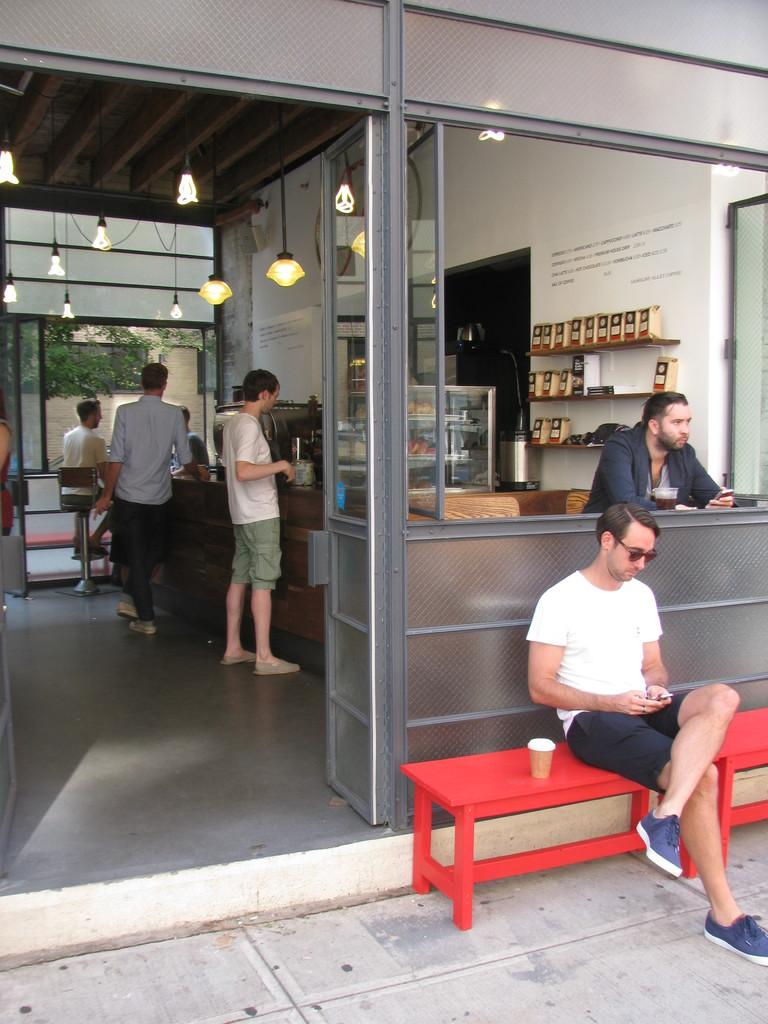What is the man in the image doing? The man is sitting on a bench in the image. Where is the man located in the image? The man is on the floor in the image. What are other people doing in the image? There are people standing on the floor in the image. What can be seen in the background or above the people in the image? There are lights visible in the image. What is the setting of the image? There is a wall in the image, which suggests an indoor or outdoor enclosed space. What type of competition is taking place in the crib in the image? There is no crib or competition present in the image; it features a man sitting on a bench and other people standing on the floor. 